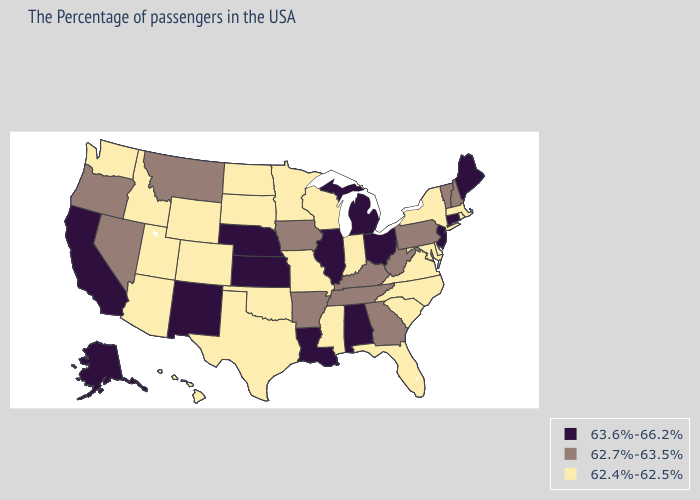Which states have the highest value in the USA?
Answer briefly. Maine, Connecticut, New Jersey, Ohio, Michigan, Alabama, Illinois, Louisiana, Kansas, Nebraska, New Mexico, California, Alaska. What is the highest value in the Northeast ?
Keep it brief. 63.6%-66.2%. What is the value of Mississippi?
Concise answer only. 62.4%-62.5%. What is the value of Wisconsin?
Keep it brief. 62.4%-62.5%. Name the states that have a value in the range 62.4%-62.5%?
Concise answer only. Massachusetts, Rhode Island, New York, Delaware, Maryland, Virginia, North Carolina, South Carolina, Florida, Indiana, Wisconsin, Mississippi, Missouri, Minnesota, Oklahoma, Texas, South Dakota, North Dakota, Wyoming, Colorado, Utah, Arizona, Idaho, Washington, Hawaii. Does Virginia have the lowest value in the South?
Quick response, please. Yes. Does Minnesota have the lowest value in the USA?
Concise answer only. Yes. What is the value of Mississippi?
Answer briefly. 62.4%-62.5%. Which states have the lowest value in the South?
Keep it brief. Delaware, Maryland, Virginia, North Carolina, South Carolina, Florida, Mississippi, Oklahoma, Texas. Does Alaska have the highest value in the West?
Be succinct. Yes. Does Hawaii have a lower value than Vermont?
Quick response, please. Yes. Which states have the highest value in the USA?
Quick response, please. Maine, Connecticut, New Jersey, Ohio, Michigan, Alabama, Illinois, Louisiana, Kansas, Nebraska, New Mexico, California, Alaska. Does Kentucky have the lowest value in the South?
Be succinct. No. Among the states that border Maine , which have the lowest value?
Short answer required. New Hampshire. Which states have the lowest value in the USA?
Answer briefly. Massachusetts, Rhode Island, New York, Delaware, Maryland, Virginia, North Carolina, South Carolina, Florida, Indiana, Wisconsin, Mississippi, Missouri, Minnesota, Oklahoma, Texas, South Dakota, North Dakota, Wyoming, Colorado, Utah, Arizona, Idaho, Washington, Hawaii. 